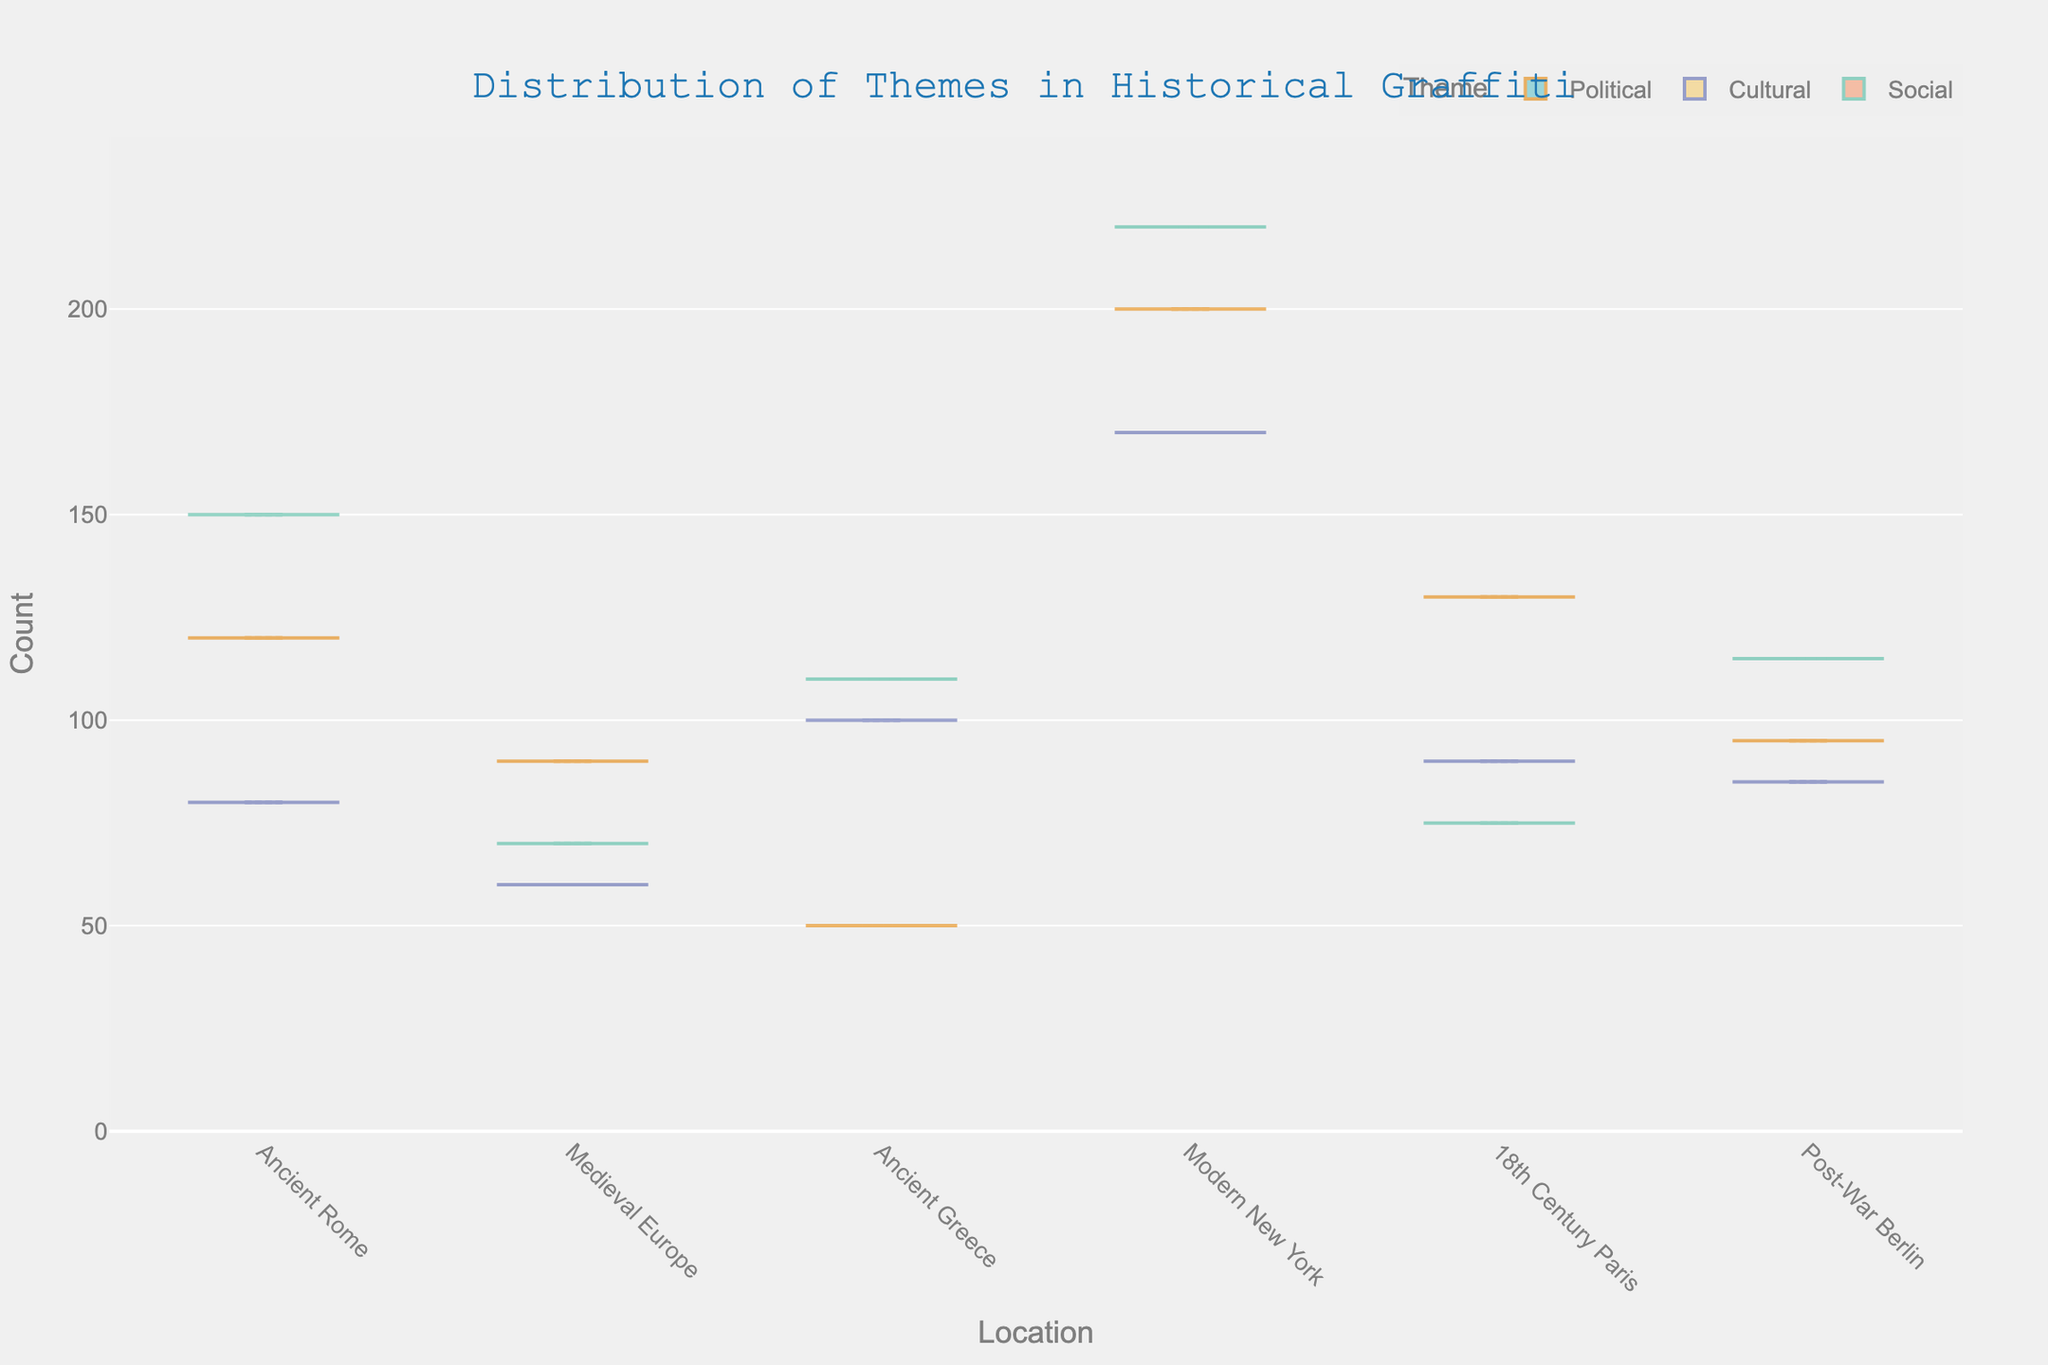Which location has the highest count of social-themed graffiti? In the figure, locate the Social theme and compare the heights of the density plots for different locations. Modern New York has the highest count.
Answer: Modern New York What is the title of the plot? The title is typically placed at the top center of the plot. Here, it reads: "Distribution of Themes in Historical Graffiti".
Answer: Distribution of Themes in Historical Graffiti How many different themes are represented in the plot? Identify the different themes displayed, which are indicated in the legend. The themes are Political, Cultural, and Social.
Answer: 3 In which location does Political graffiti have the lowest count? Compare the Political violin plots for all locations; Ancient Greece has the shortest plot for Political graffiti.
Answer: Ancient Greece Which theme shows a higher count in Ancient Rome, Social or Cultural? Look at the height of the Social and Cultural density plots in Ancient Rome; Social is higher than Cultural.
Answer: Social What is the approximate range of counts for Cultural graffiti in Modern New York? Observe the span of the Cultural density plot in Modern New York from top to bottom: approximately from 170 to 170 (indicating consistency).
Answer: Around 170 Which locations have higher counts for Cultural graffiti compared to Political graffiti? Compare the height of the Cultural and the Political plots for each location: Ancient Greece and Modern New York have higher Cultural graffiti counts than Political graffiti.
Answer: Ancient Greece, Modern New York What is the count difference between Social graffiti in 18th Century Paris and Post-War Berlin? Identify the counts for Social in 18th Century Paris (75) and Post-War Berlin (115), then find the difference: 115 - 75 = 40.
Answer: 40 Which location has more Cultural graffiti, Medieval Europe or Post-War Berlin? Compare the Cultural plots; although they are close, Post-War Berlin slightly surpasses Medieval Europe.
Answer: Post-War Berlin 